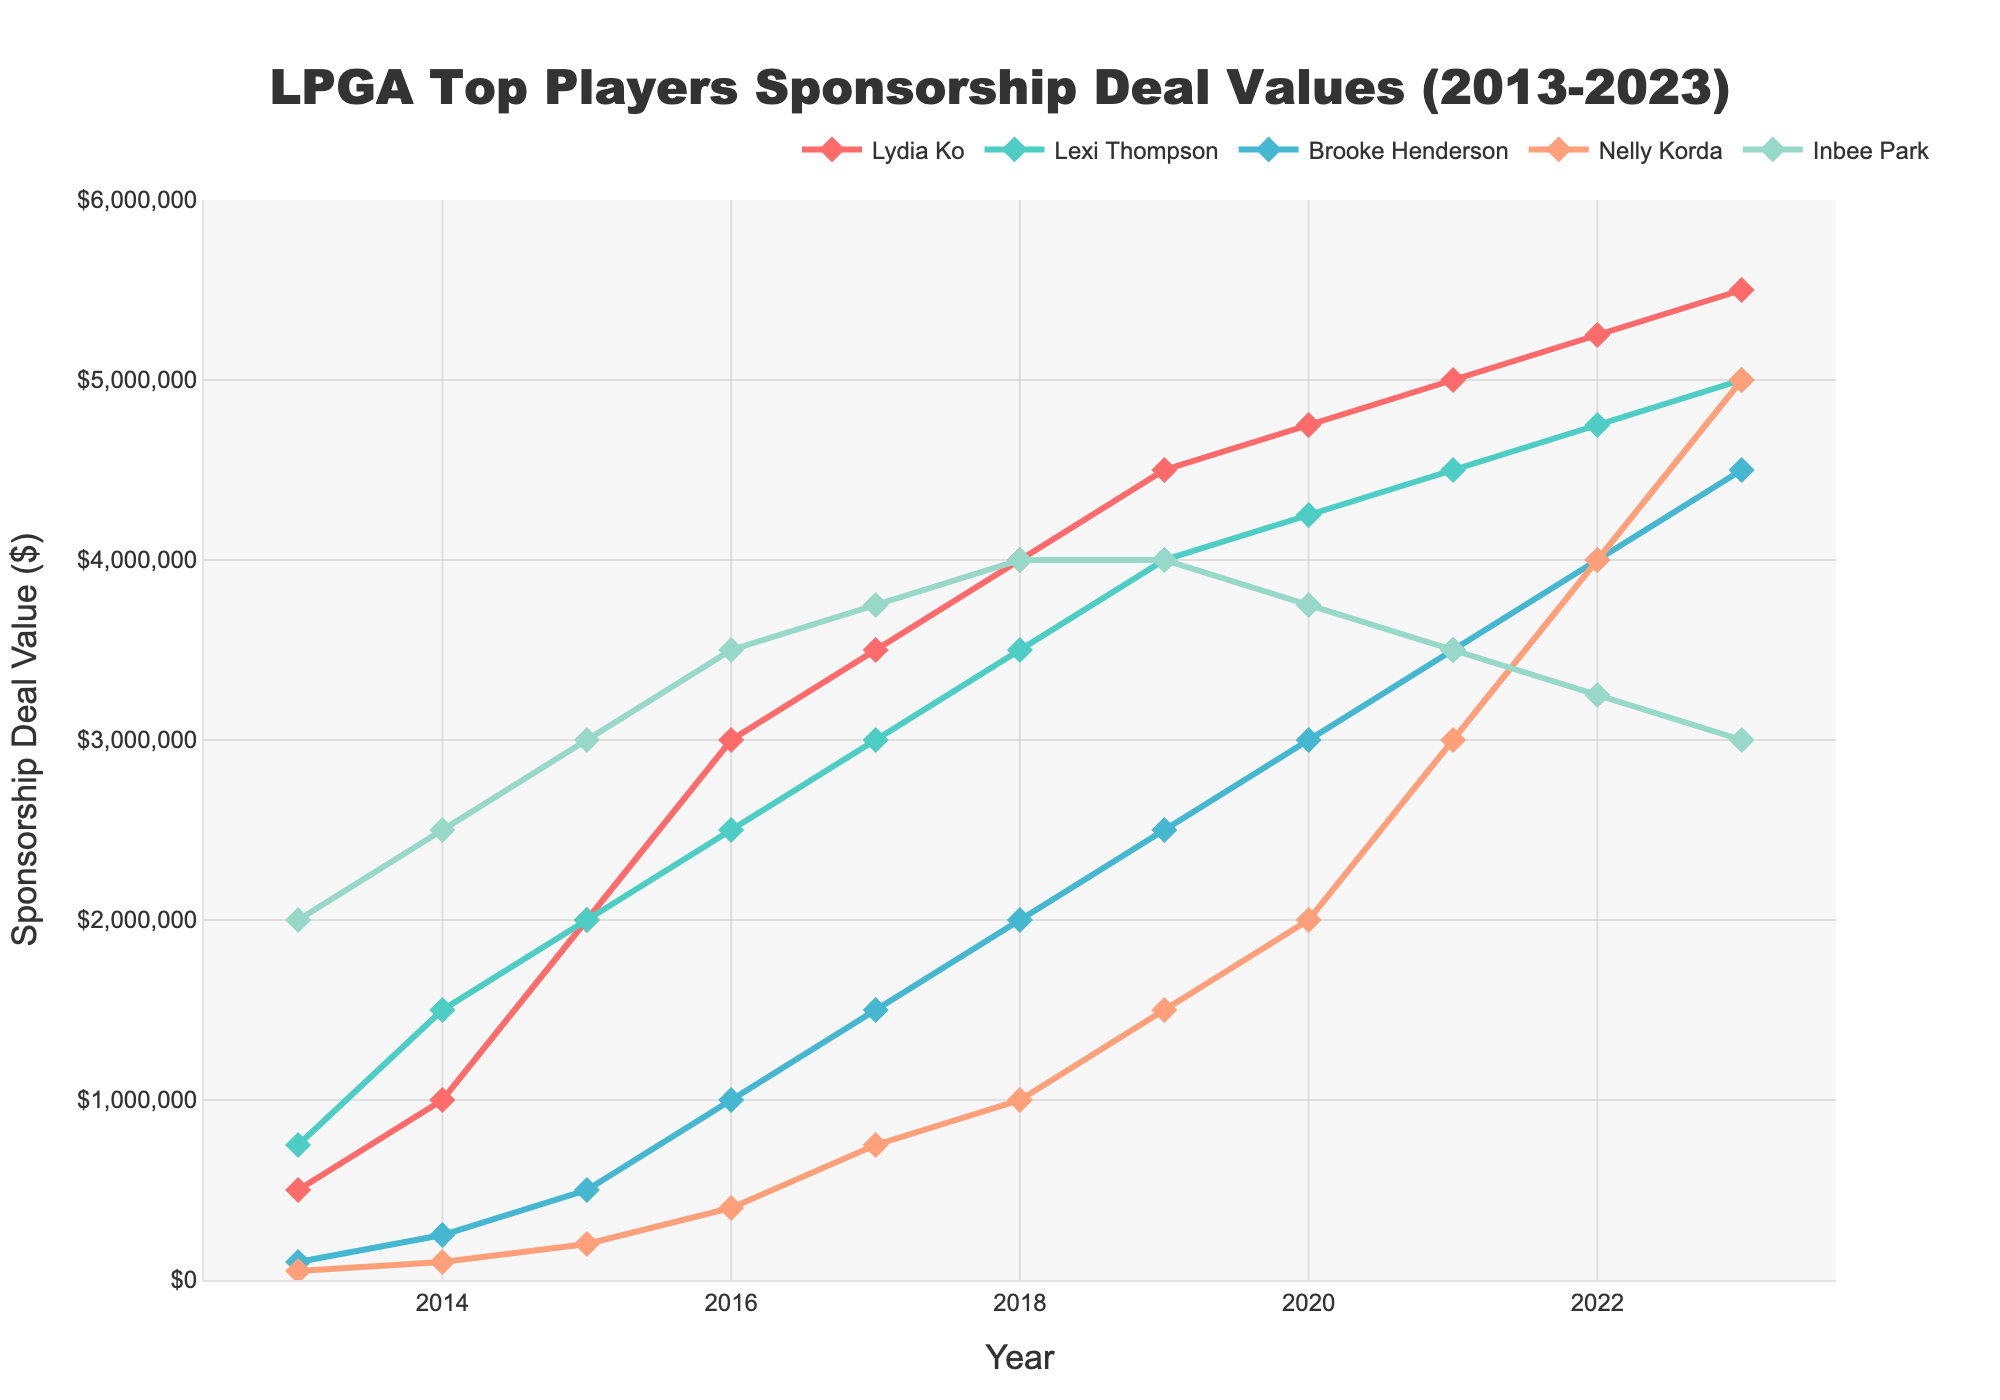What's the trend for Lydia Ko's sponsorship deal value over the last decade? Lydia Ko's sponsorship deal value shows a consistent upward trend from $500,000 in 2013 to $5,500,000 in 2023, increasing almost every year.
Answer: Upward Which player had the highest sponsorship deal value in 2013? Based on the 2013 data, the player with the highest sponsorship deal value was Inbee Park with $2,000,000.
Answer: Inbee Park In 2023, whose sponsorship deal value was equal to Nelly Korda's? In the plot for the year 2023, both Nelly Korda and Lydia Ko had a sponsorship deal value of $5,000,000.
Answer: Lydia Ko What was the average sponsorship deal value for Lexi Thompson in 2019 and 2020? In 2019, Lexi Thompson's value was $4,000,000, and in 2020, it was $4,250,000. Adding these gives $8,250,000, and dividing by 2 gives an average of $4,125,000.
Answer: $4,125,000 Between 2014 and 2018, which player's sponsorship deal value increased the most? Lydia Ko's sponsorship deal increased from $1,000,000 in 2014 to $4,000,000 in 2018. This is an increase of $3,000,000, which is the most among the players.
Answer: Lydia Ko Comparing the values for 2023, which player has the smallest sponsorship deal value? In the year 2023, Inbee Park has the smallest sponsorship deal value at $3,000,000.
Answer: Inbee Park What is the combined sponsorship deal value of all players in 2021? Adding the 2021 values: Lydia Ko ($5,000,000), Lexi Thompson ($4,500,000), Brooke Henderson ($3,500,000), Nelly Korda ($3,000,000), and Inbee Park ($3,500,000) gives a total of $19,500,000.
Answer: $19,500,000 From 2018 to 2020, which player had a consistent increase in sponsorship deal value each year? Brooke Henderson had consistent increases from $2,000,000 in 2018, to $2,500,000 in 2019, and to $3,000,000 in 2020.
Answer: Brooke Henderson What is the difference in Lydia Ko's sponsorship deal value between 2017 and 2023? In 2017, Lydia Ko's value was $3,500,000, and in 2023 it was $5,500,000. The difference is $5,500,000 - $3,500,000 = $2,000,000.
Answer: $2,000,000 